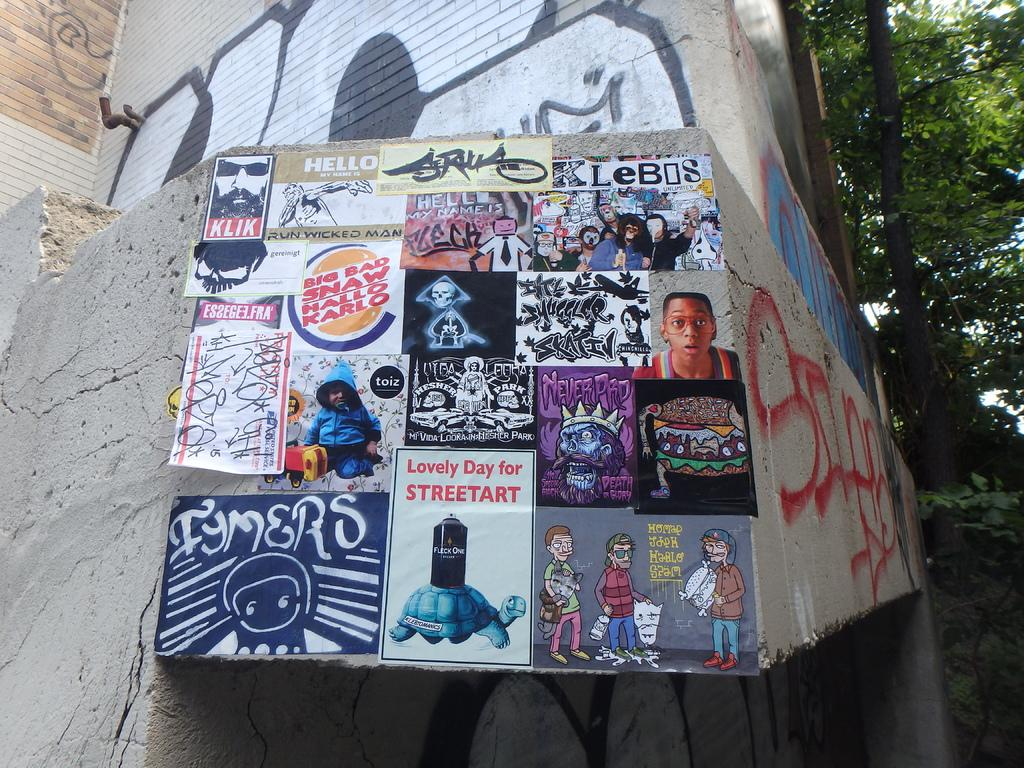What is the main structure visible in the image? There is a building in the image. What can be seen on the wall of the building? There are posters on the wall of the building. What type of natural scenery is visible in the background of the image? There are trees in the background of the image. Can you describe the woman holding a spark in the image? There is no woman holding a spark in the image; the provided facts do not mention a building, posters, and trees, but not a woman or a spark. 